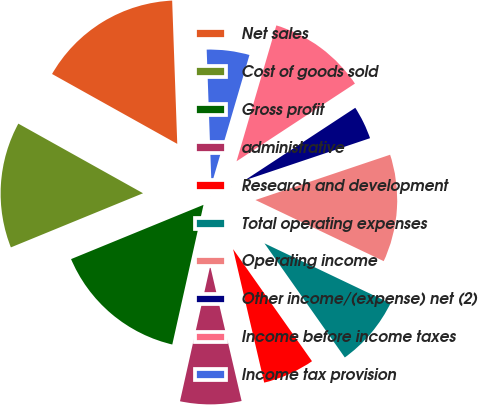<chart> <loc_0><loc_0><loc_500><loc_500><pie_chart><fcel>Net sales<fcel>Cost of goods sold<fcel>Gross profit<fcel>administrative<fcel>Research and development<fcel>Total operating expenses<fcel>Operating income<fcel>Other income/(expense) net (2)<fcel>Income before income taxes<fcel>Income tax provision<nl><fcel>16.33%<fcel>14.29%<fcel>15.31%<fcel>7.14%<fcel>6.12%<fcel>8.16%<fcel>12.24%<fcel>4.08%<fcel>11.22%<fcel>5.1%<nl></chart> 